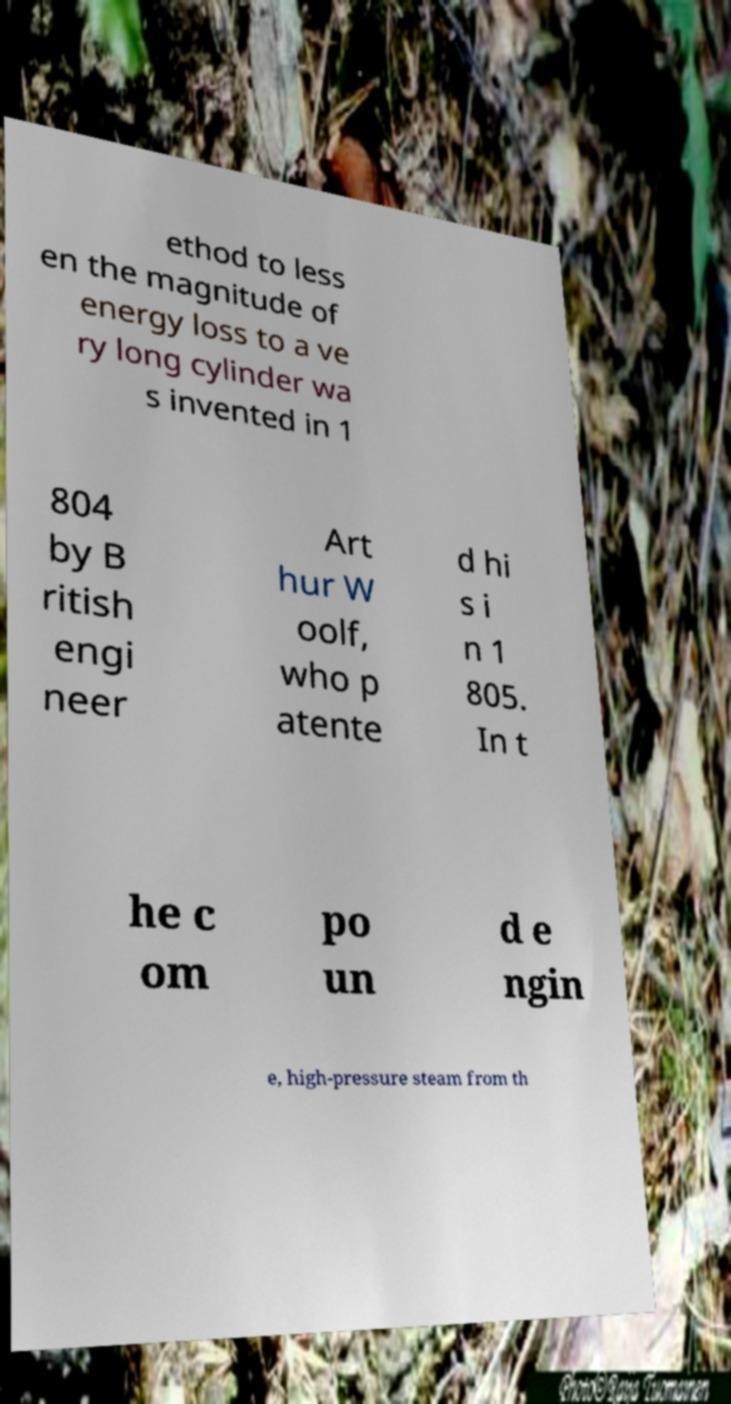Can you read and provide the text displayed in the image?This photo seems to have some interesting text. Can you extract and type it out for me? ethod to less en the magnitude of energy loss to a ve ry long cylinder wa s invented in 1 804 by B ritish engi neer Art hur W oolf, who p atente d hi s i n 1 805. In t he c om po un d e ngin e, high-pressure steam from th 